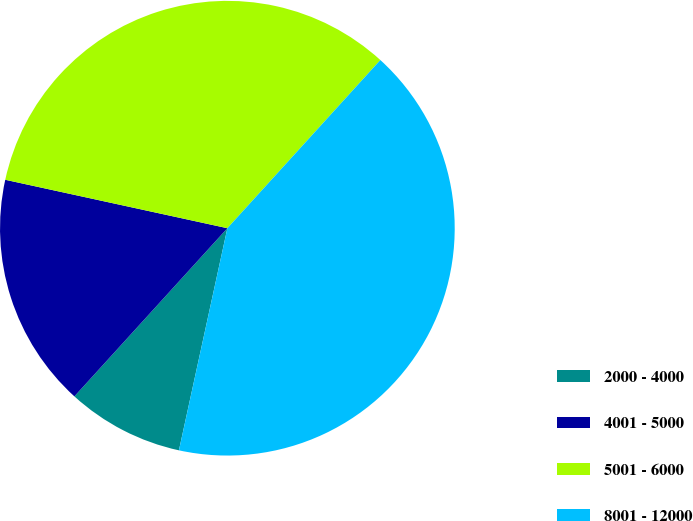Convert chart. <chart><loc_0><loc_0><loc_500><loc_500><pie_chart><fcel>2000 - 4000<fcel>4001 - 5000<fcel>5001 - 6000<fcel>8001 - 12000<nl><fcel>8.33%<fcel>16.67%<fcel>33.33%<fcel>41.67%<nl></chart> 